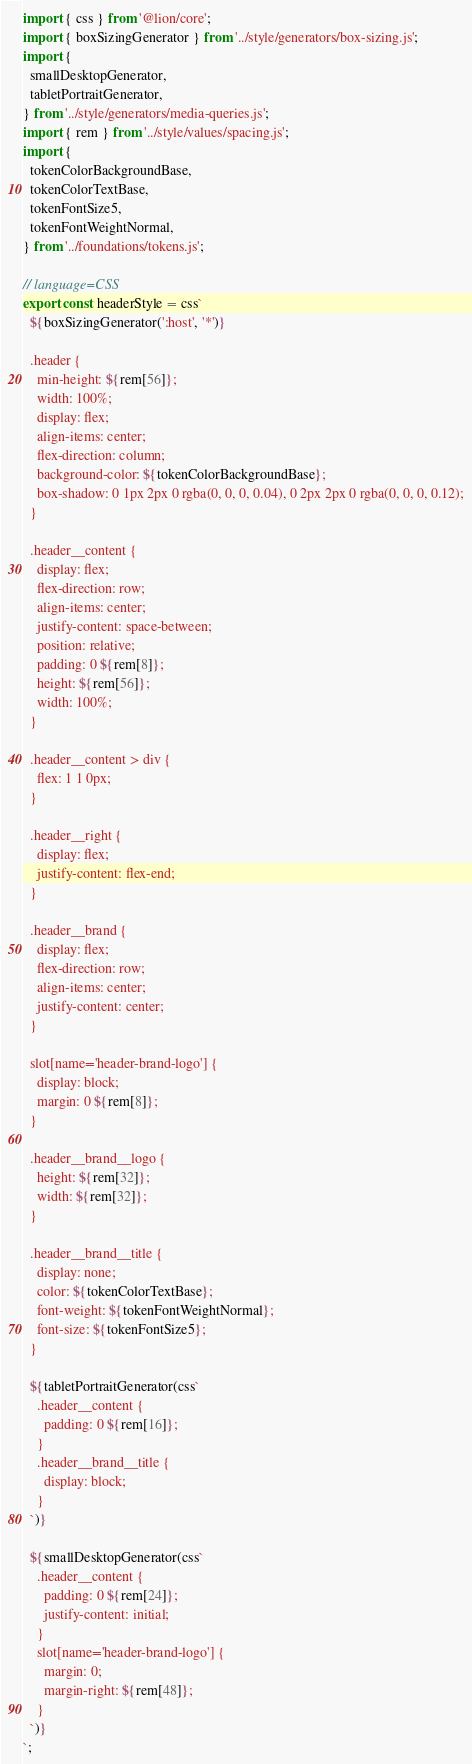<code> <loc_0><loc_0><loc_500><loc_500><_JavaScript_>import { css } from '@lion/core';
import { boxSizingGenerator } from '../style/generators/box-sizing.js';
import {
  smallDesktopGenerator,
  tabletPortraitGenerator,
} from '../style/generators/media-queries.js';
import { rem } from '../style/values/spacing.js';
import {
  tokenColorBackgroundBase,
  tokenColorTextBase,
  tokenFontSize5,
  tokenFontWeightNormal,
} from '../foundations/tokens.js';

// language=CSS
export const headerStyle = css`
  ${boxSizingGenerator(':host', '*')}

  .header {
    min-height: ${rem[56]};
    width: 100%;
    display: flex;
    align-items: center;
    flex-direction: column;
    background-color: ${tokenColorBackgroundBase};
    box-shadow: 0 1px 2px 0 rgba(0, 0, 0, 0.04), 0 2px 2px 0 rgba(0, 0, 0, 0.12);
  }

  .header__content {
    display: flex;
    flex-direction: row;
    align-items: center;
    justify-content: space-between;
    position: relative;
    padding: 0 ${rem[8]};
    height: ${rem[56]};
    width: 100%;
  }

  .header__content > div {
    flex: 1 1 0px;
  }

  .header__right {
    display: flex;
    justify-content: flex-end;
  }

  .header__brand {
    display: flex;
    flex-direction: row;
    align-items: center;
    justify-content: center;
  }

  slot[name='header-brand-logo'] {
    display: block;
    margin: 0 ${rem[8]};
  }

  .header__brand__logo {
    height: ${rem[32]};
    width: ${rem[32]};
  }

  .header__brand__title {
    display: none;
    color: ${tokenColorTextBase};
    font-weight: ${tokenFontWeightNormal};
    font-size: ${tokenFontSize5};
  }

  ${tabletPortraitGenerator(css`
    .header__content {
      padding: 0 ${rem[16]};
    }
    .header__brand__title {
      display: block;
    }
  `)}

  ${smallDesktopGenerator(css`
    .header__content {
      padding: 0 ${rem[24]};
      justify-content: initial;
    }
    slot[name='header-brand-logo'] {
      margin: 0;
      margin-right: ${rem[48]};
    }
  `)}
`;
</code> 